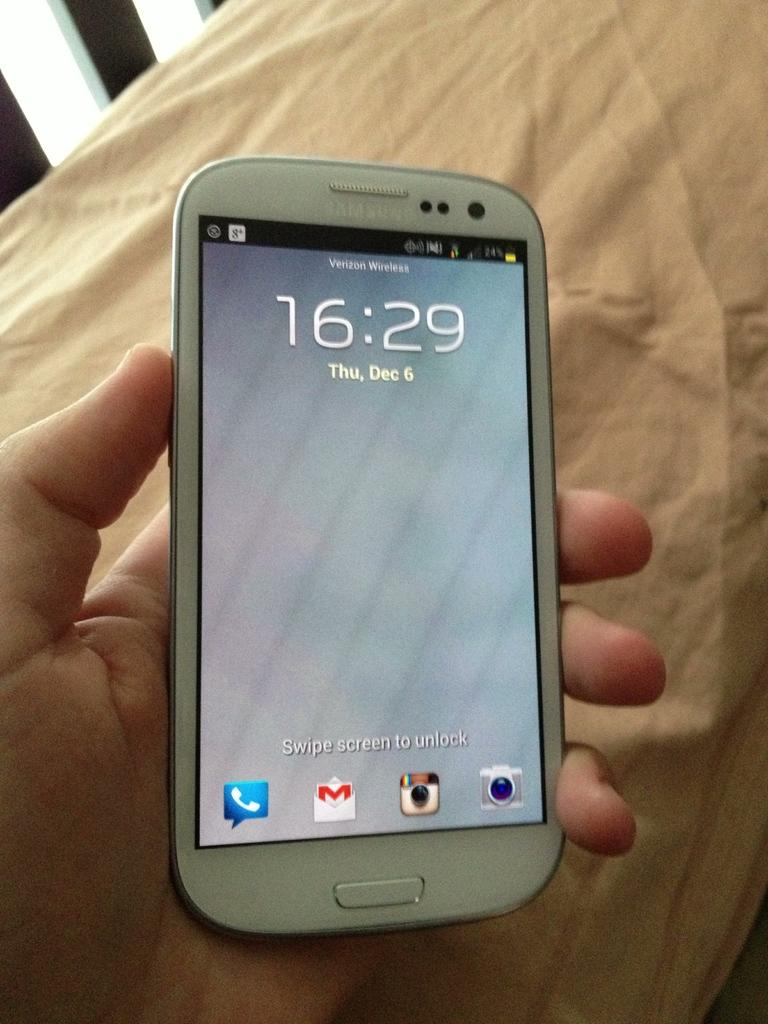<image>
Offer a succinct explanation of the picture presented. A Samsung phone shows the time as 16:29 on Dec 6 